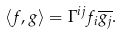<formula> <loc_0><loc_0><loc_500><loc_500>\langle f , g \rangle = \Gamma ^ { i j } f _ { i } \overline { g _ { j } } .</formula> 